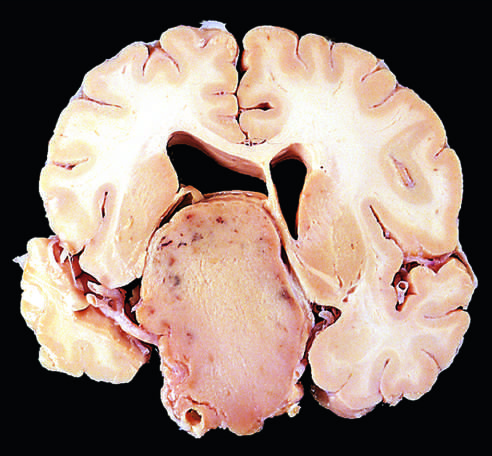what tend to be larger at the time of diagnosis than those that secrete a hormone?
Answer the question using a single word or phrase. Nonfunctioning adenomas 